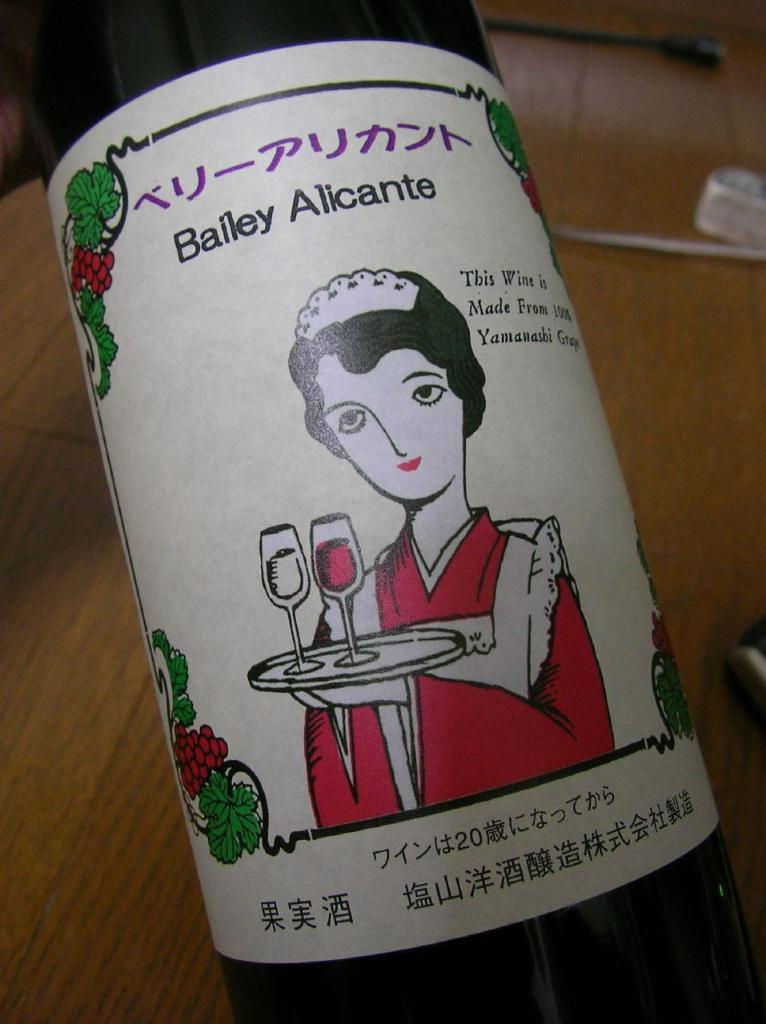What type of container is visible in the image? There is a glass bottle in the image. What can be found on the glass bottle? The glass bottle has a label. What is the person in the image holding? The person in the image is holding a plate. What is on the plate that the person is holding? The plate contains wine glasses. What type of surface is present in the image? There is a wooden surface in the image. How many rings are visible on the person's fingers in the image? There are no rings visible on the person's fingers in the image. What type of car is parked next to the wooden surface in the image? There is no car present in the image; it only features a glass bottle, a person holding a plate, and a wooden surface. 